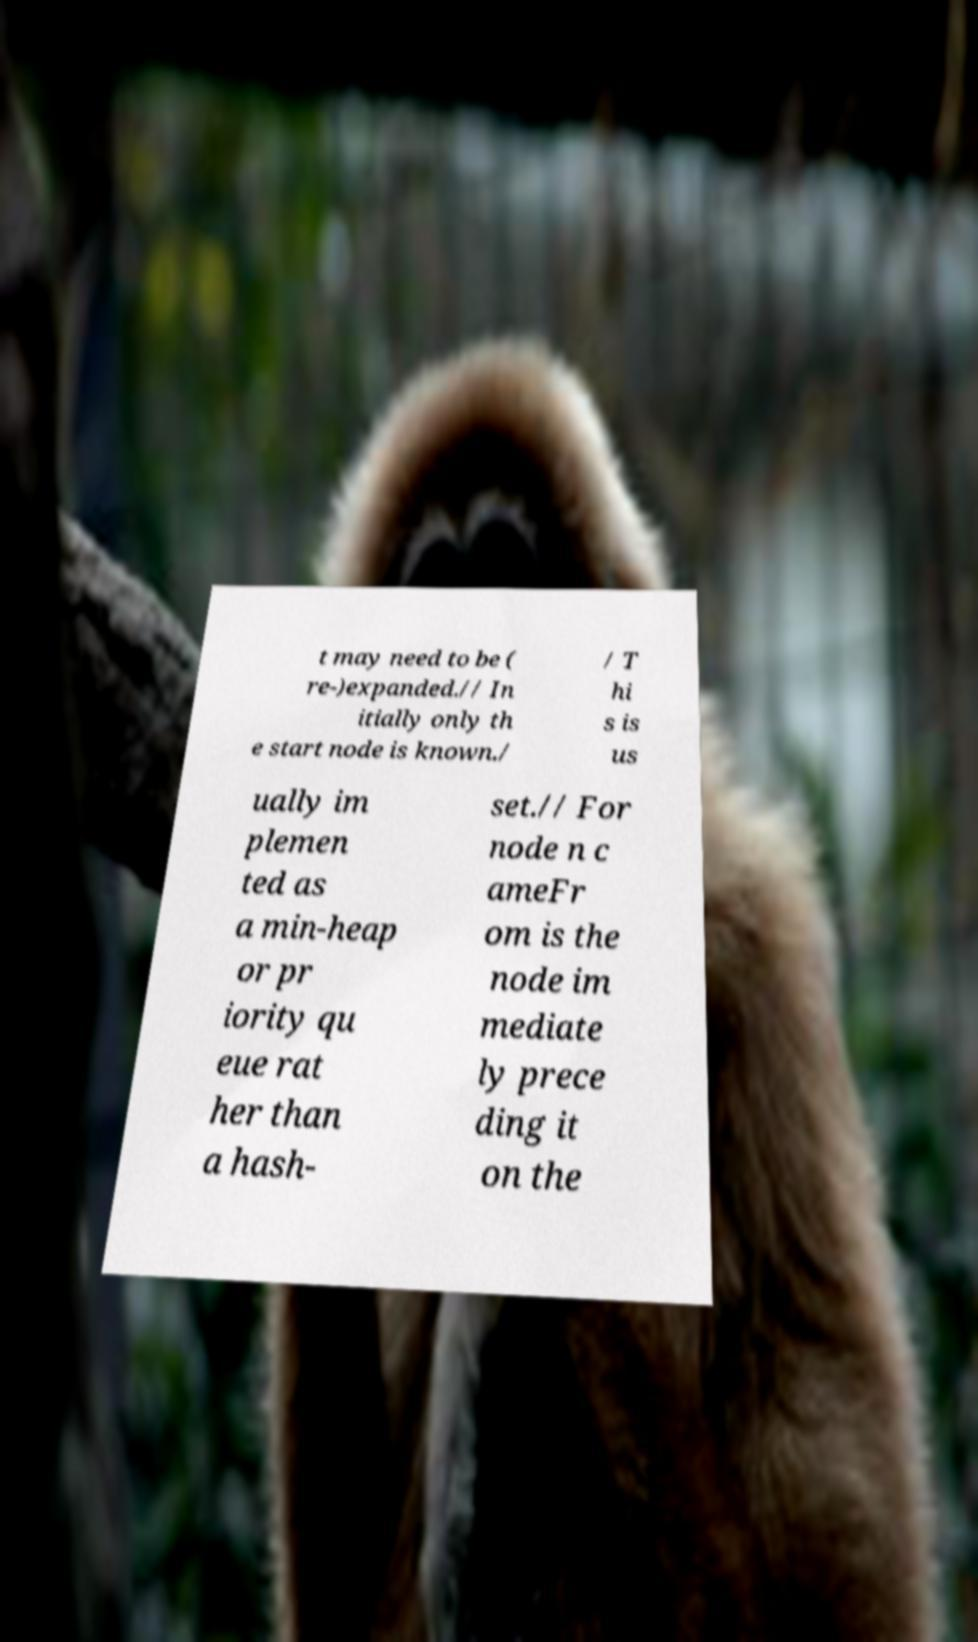Could you extract and type out the text from this image? t may need to be ( re-)expanded.// In itially only th e start node is known./ / T hi s is us ually im plemen ted as a min-heap or pr iority qu eue rat her than a hash- set.// For node n c ameFr om is the node im mediate ly prece ding it on the 